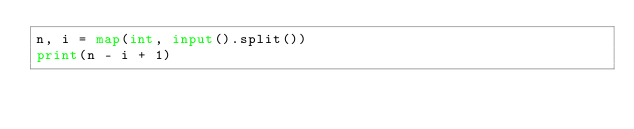Convert code to text. <code><loc_0><loc_0><loc_500><loc_500><_Python_>n, i = map(int, input().split())
print(n - i + 1)</code> 